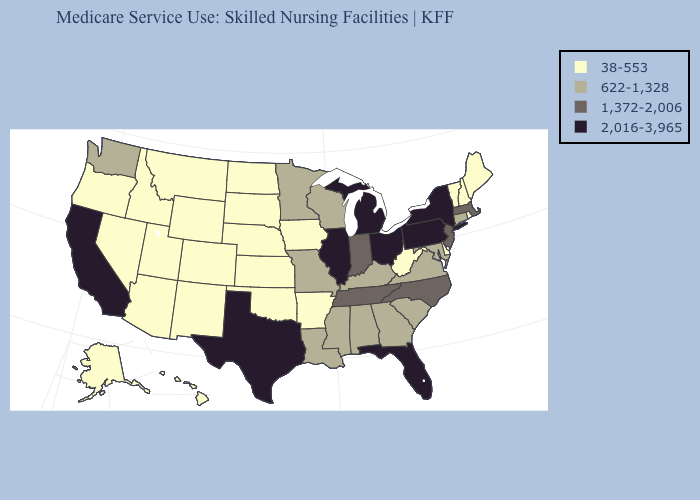Does Arizona have the highest value in the West?
Quick response, please. No. How many symbols are there in the legend?
Answer briefly. 4. What is the highest value in the USA?
Answer briefly. 2,016-3,965. Does California have the lowest value in the USA?
Give a very brief answer. No. What is the value of Iowa?
Keep it brief. 38-553. Does the first symbol in the legend represent the smallest category?
Short answer required. Yes. Does Ohio have a lower value than Vermont?
Keep it brief. No. Is the legend a continuous bar?
Short answer required. No. Name the states that have a value in the range 1,372-2,006?
Quick response, please. Indiana, Massachusetts, New Jersey, North Carolina, Tennessee. Is the legend a continuous bar?
Answer briefly. No. Does Oklahoma have the lowest value in the USA?
Concise answer only. Yes. Is the legend a continuous bar?
Give a very brief answer. No. Name the states that have a value in the range 38-553?
Concise answer only. Alaska, Arizona, Arkansas, Colorado, Delaware, Hawaii, Idaho, Iowa, Kansas, Maine, Montana, Nebraska, Nevada, New Hampshire, New Mexico, North Dakota, Oklahoma, Oregon, Rhode Island, South Dakota, Utah, Vermont, West Virginia, Wyoming. What is the value of Alaska?
Quick response, please. 38-553. Name the states that have a value in the range 2,016-3,965?
Give a very brief answer. California, Florida, Illinois, Michigan, New York, Ohio, Pennsylvania, Texas. 